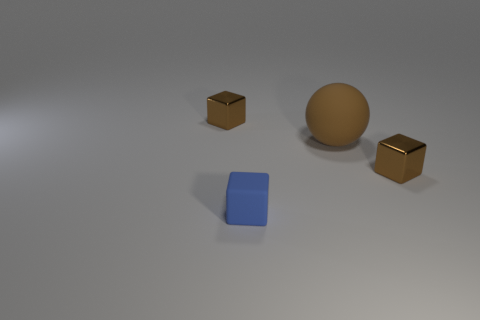Are there any blocks that are in front of the brown metallic object on the right side of the matte block?
Provide a succinct answer. Yes. There is a object that is made of the same material as the tiny blue cube; what size is it?
Offer a very short reply. Large. What size is the shiny object on the right side of the rubber thing right of the tiny blue rubber object?
Offer a terse response. Small. There is a large thing to the right of the tiny brown object that is behind the small brown object on the right side of the tiny blue rubber thing; what is its color?
Keep it short and to the point. Brown. Does the tiny cube that is on the left side of the blue block have the same color as the cube that is right of the large brown thing?
Give a very brief answer. Yes. There is a blue thing; does it have the same shape as the shiny thing that is on the right side of the small blue matte thing?
Provide a succinct answer. Yes. Are there fewer rubber objects that are in front of the small blue matte cube than small brown cubes that are to the right of the big matte object?
Provide a succinct answer. Yes. Is the shape of the brown matte object the same as the tiny blue rubber thing?
Ensure brevity in your answer.  No. Is there anything else that has the same material as the big brown thing?
Your answer should be very brief. Yes. What is the size of the matte sphere?
Give a very brief answer. Large. 